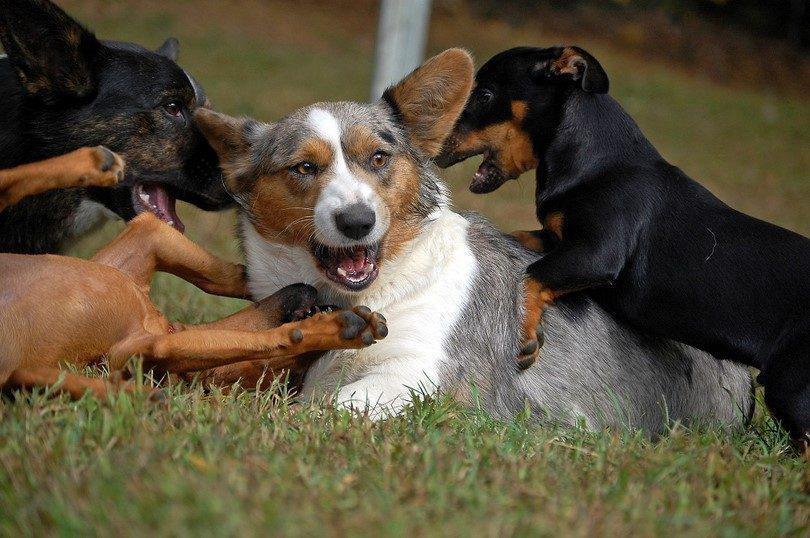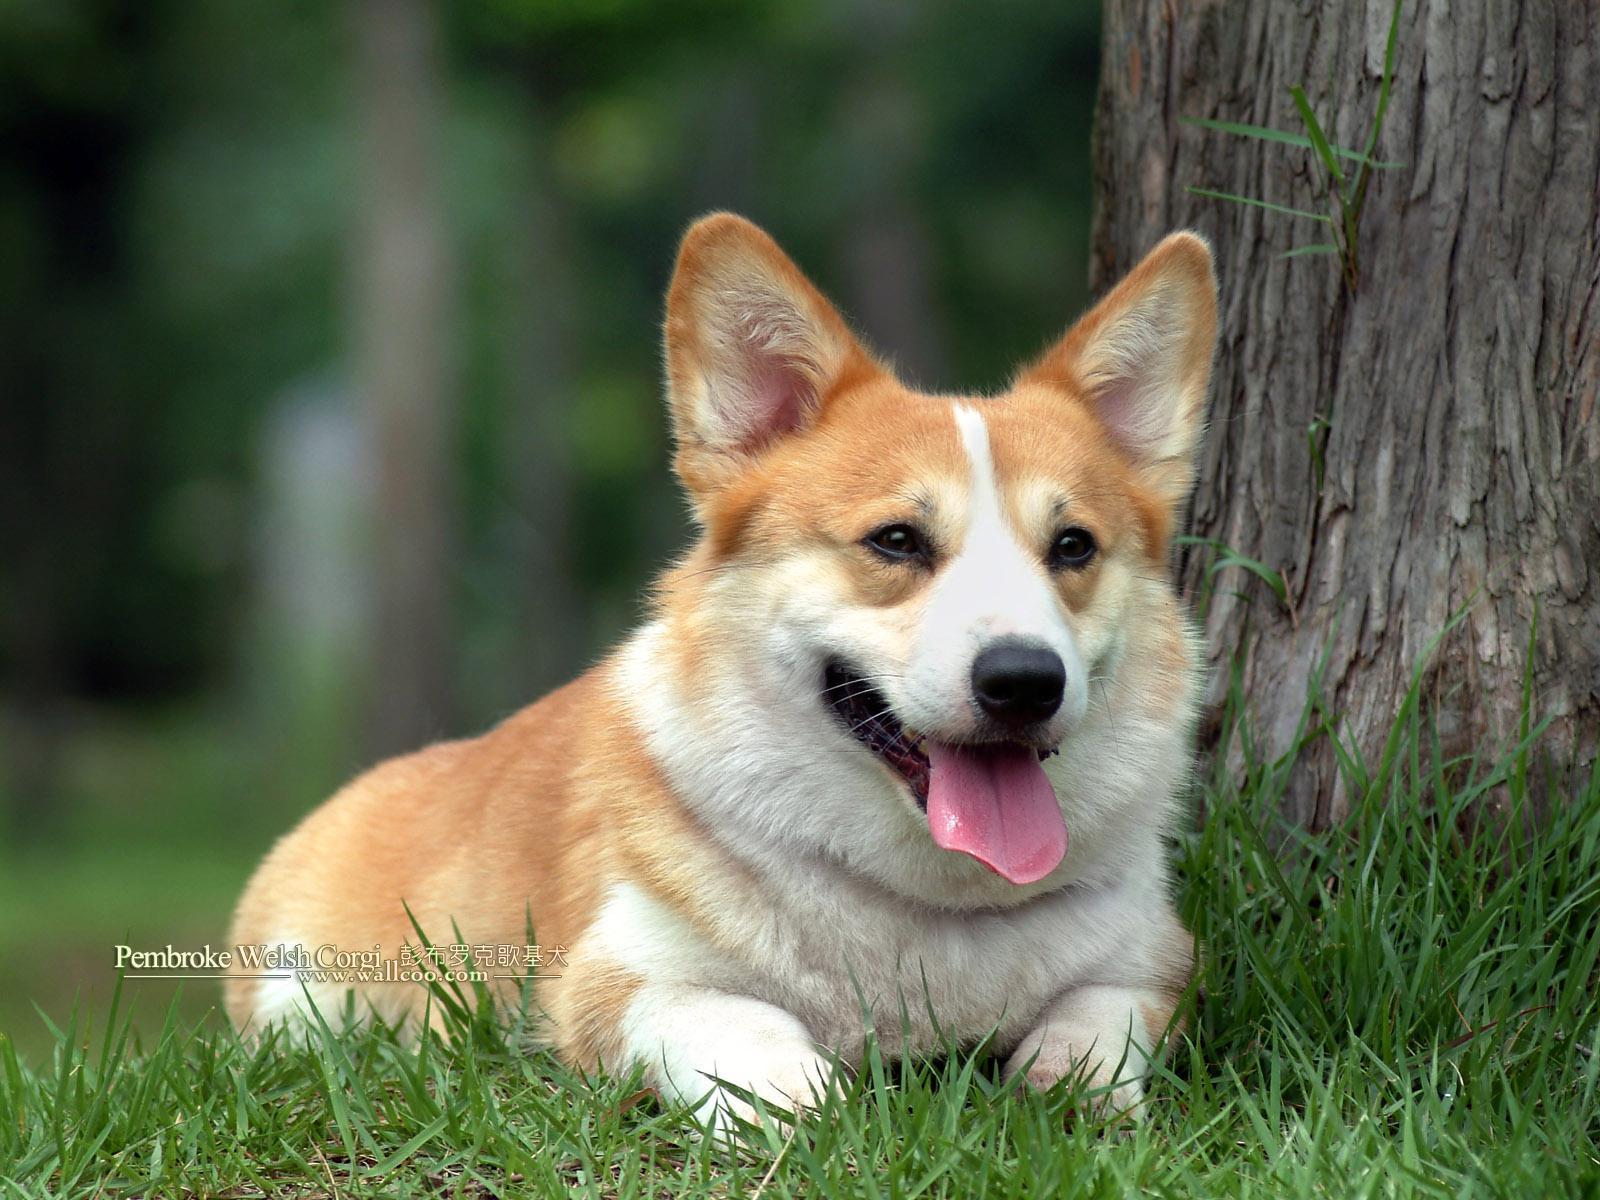The first image is the image on the left, the second image is the image on the right. Considering the images on both sides, is "One dog has his mouth shut." valid? Answer yes or no. No. The first image is the image on the left, the second image is the image on the right. Examine the images to the left and right. Is the description "The dogs are all either standing or sitting while looking at the camera." accurate? Answer yes or no. No. 